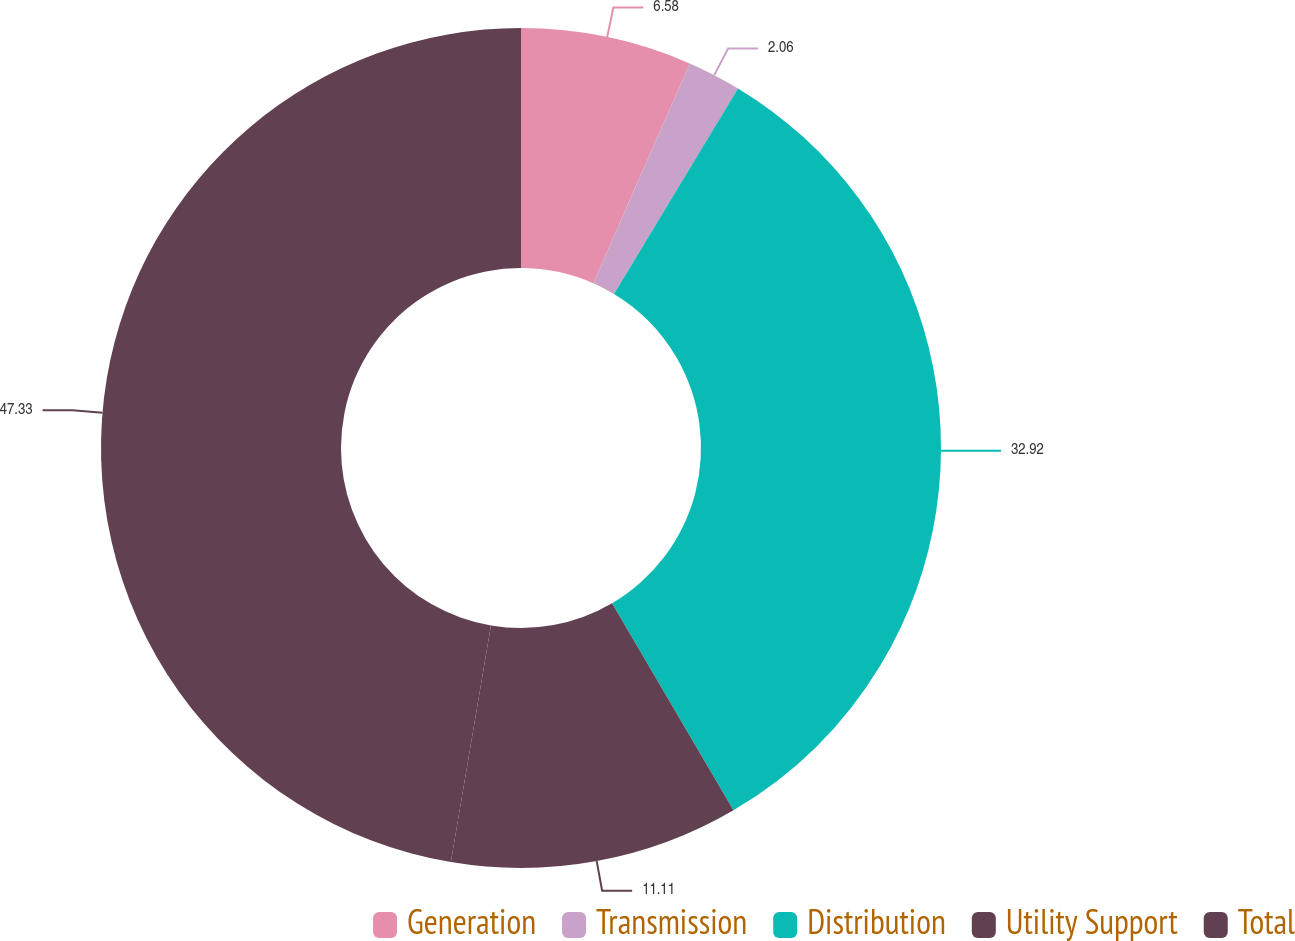Convert chart to OTSL. <chart><loc_0><loc_0><loc_500><loc_500><pie_chart><fcel>Generation<fcel>Transmission<fcel>Distribution<fcel>Utility Support<fcel>Total<nl><fcel>6.58%<fcel>2.06%<fcel>32.92%<fcel>11.11%<fcel>47.33%<nl></chart> 